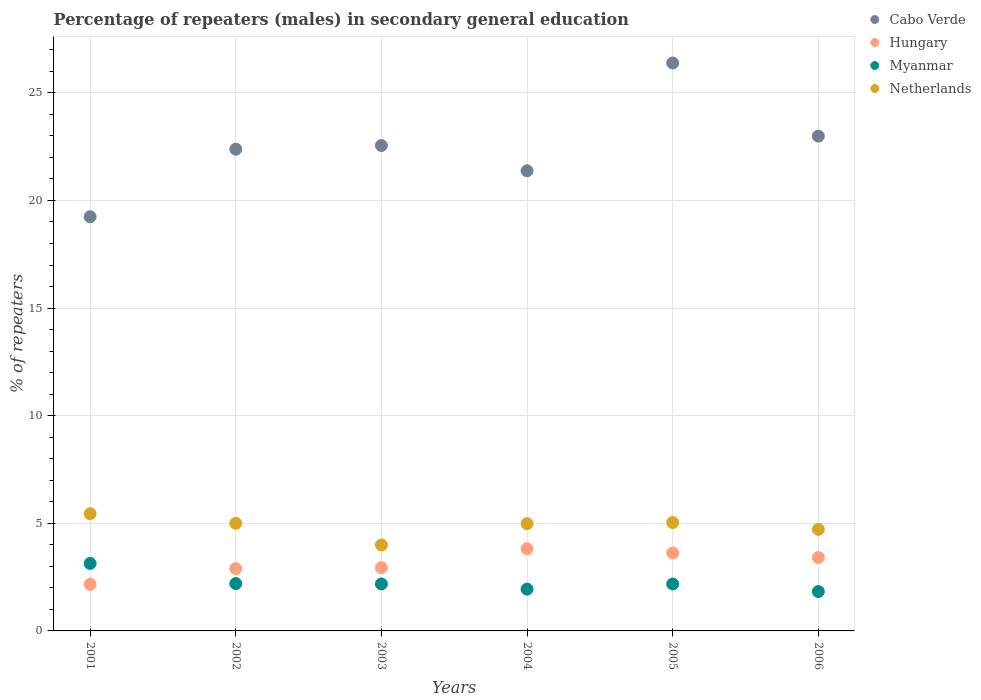How many different coloured dotlines are there?
Provide a succinct answer. 4. Is the number of dotlines equal to the number of legend labels?
Offer a very short reply. Yes. What is the percentage of male repeaters in Hungary in 2001?
Offer a very short reply. 2.16. Across all years, what is the maximum percentage of male repeaters in Cabo Verde?
Make the answer very short. 26.39. Across all years, what is the minimum percentage of male repeaters in Myanmar?
Make the answer very short. 1.83. What is the total percentage of male repeaters in Myanmar in the graph?
Provide a short and direct response. 13.47. What is the difference between the percentage of male repeaters in Myanmar in 2001 and that in 2005?
Offer a very short reply. 0.95. What is the difference between the percentage of male repeaters in Myanmar in 2002 and the percentage of male repeaters in Cabo Verde in 2003?
Offer a terse response. -20.35. What is the average percentage of male repeaters in Hungary per year?
Provide a short and direct response. 3.14. In the year 2002, what is the difference between the percentage of male repeaters in Hungary and percentage of male repeaters in Cabo Verde?
Your response must be concise. -19.49. In how many years, is the percentage of male repeaters in Hungary greater than 16 %?
Make the answer very short. 0. What is the ratio of the percentage of male repeaters in Netherlands in 2001 to that in 2003?
Give a very brief answer. 1.36. Is the difference between the percentage of male repeaters in Hungary in 2004 and 2005 greater than the difference between the percentage of male repeaters in Cabo Verde in 2004 and 2005?
Provide a short and direct response. Yes. What is the difference between the highest and the second highest percentage of male repeaters in Hungary?
Keep it short and to the point. 0.2. What is the difference between the highest and the lowest percentage of male repeaters in Cabo Verde?
Offer a very short reply. 7.14. Is the sum of the percentage of male repeaters in Hungary in 2002 and 2006 greater than the maximum percentage of male repeaters in Myanmar across all years?
Your answer should be compact. Yes. Is it the case that in every year, the sum of the percentage of male repeaters in Cabo Verde and percentage of male repeaters in Myanmar  is greater than the sum of percentage of male repeaters in Netherlands and percentage of male repeaters in Hungary?
Provide a succinct answer. No. Does the percentage of male repeaters in Netherlands monotonically increase over the years?
Your response must be concise. No. Is the percentage of male repeaters in Cabo Verde strictly greater than the percentage of male repeaters in Myanmar over the years?
Give a very brief answer. Yes. How many dotlines are there?
Keep it short and to the point. 4. Are the values on the major ticks of Y-axis written in scientific E-notation?
Give a very brief answer. No. Does the graph contain grids?
Your response must be concise. Yes. How many legend labels are there?
Your response must be concise. 4. What is the title of the graph?
Your response must be concise. Percentage of repeaters (males) in secondary general education. Does "Macedonia" appear as one of the legend labels in the graph?
Make the answer very short. No. What is the label or title of the X-axis?
Provide a succinct answer. Years. What is the label or title of the Y-axis?
Make the answer very short. % of repeaters. What is the % of repeaters of Cabo Verde in 2001?
Make the answer very short. 19.24. What is the % of repeaters in Hungary in 2001?
Keep it short and to the point. 2.16. What is the % of repeaters in Myanmar in 2001?
Offer a terse response. 3.13. What is the % of repeaters of Netherlands in 2001?
Keep it short and to the point. 5.45. What is the % of repeaters in Cabo Verde in 2002?
Your answer should be very brief. 22.38. What is the % of repeaters in Hungary in 2002?
Your answer should be very brief. 2.89. What is the % of repeaters in Myanmar in 2002?
Provide a short and direct response. 2.2. What is the % of repeaters in Netherlands in 2002?
Offer a very short reply. 5. What is the % of repeaters in Cabo Verde in 2003?
Keep it short and to the point. 22.55. What is the % of repeaters in Hungary in 2003?
Ensure brevity in your answer.  2.94. What is the % of repeaters in Myanmar in 2003?
Give a very brief answer. 2.18. What is the % of repeaters in Netherlands in 2003?
Ensure brevity in your answer.  3.99. What is the % of repeaters in Cabo Verde in 2004?
Offer a very short reply. 21.38. What is the % of repeaters of Hungary in 2004?
Ensure brevity in your answer.  3.82. What is the % of repeaters in Myanmar in 2004?
Keep it short and to the point. 1.94. What is the % of repeaters in Netherlands in 2004?
Provide a succinct answer. 4.99. What is the % of repeaters in Cabo Verde in 2005?
Ensure brevity in your answer.  26.39. What is the % of repeaters in Hungary in 2005?
Your answer should be compact. 3.62. What is the % of repeaters of Myanmar in 2005?
Give a very brief answer. 2.18. What is the % of repeaters in Netherlands in 2005?
Keep it short and to the point. 5.04. What is the % of repeaters of Cabo Verde in 2006?
Your answer should be compact. 22.99. What is the % of repeaters of Hungary in 2006?
Your answer should be compact. 3.41. What is the % of repeaters in Myanmar in 2006?
Your answer should be compact. 1.83. What is the % of repeaters of Netherlands in 2006?
Your answer should be compact. 4.72. Across all years, what is the maximum % of repeaters of Cabo Verde?
Offer a very short reply. 26.39. Across all years, what is the maximum % of repeaters in Hungary?
Provide a succinct answer. 3.82. Across all years, what is the maximum % of repeaters of Myanmar?
Your answer should be compact. 3.13. Across all years, what is the maximum % of repeaters of Netherlands?
Give a very brief answer. 5.45. Across all years, what is the minimum % of repeaters of Cabo Verde?
Give a very brief answer. 19.24. Across all years, what is the minimum % of repeaters in Hungary?
Provide a succinct answer. 2.16. Across all years, what is the minimum % of repeaters of Myanmar?
Keep it short and to the point. 1.83. Across all years, what is the minimum % of repeaters in Netherlands?
Your answer should be very brief. 3.99. What is the total % of repeaters in Cabo Verde in the graph?
Ensure brevity in your answer.  134.93. What is the total % of repeaters of Hungary in the graph?
Keep it short and to the point. 18.85. What is the total % of repeaters in Myanmar in the graph?
Your response must be concise. 13.47. What is the total % of repeaters in Netherlands in the graph?
Ensure brevity in your answer.  29.18. What is the difference between the % of repeaters of Cabo Verde in 2001 and that in 2002?
Your answer should be compact. -3.14. What is the difference between the % of repeaters of Hungary in 2001 and that in 2002?
Your answer should be compact. -0.73. What is the difference between the % of repeaters in Myanmar in 2001 and that in 2002?
Your answer should be very brief. 0.94. What is the difference between the % of repeaters in Netherlands in 2001 and that in 2002?
Your answer should be very brief. 0.45. What is the difference between the % of repeaters of Cabo Verde in 2001 and that in 2003?
Provide a short and direct response. -3.31. What is the difference between the % of repeaters of Hungary in 2001 and that in 2003?
Your response must be concise. -0.78. What is the difference between the % of repeaters in Myanmar in 2001 and that in 2003?
Offer a terse response. 0.95. What is the difference between the % of repeaters in Netherlands in 2001 and that in 2003?
Your response must be concise. 1.46. What is the difference between the % of repeaters in Cabo Verde in 2001 and that in 2004?
Keep it short and to the point. -2.13. What is the difference between the % of repeaters of Hungary in 2001 and that in 2004?
Your answer should be compact. -1.65. What is the difference between the % of repeaters in Myanmar in 2001 and that in 2004?
Provide a short and direct response. 1.19. What is the difference between the % of repeaters of Netherlands in 2001 and that in 2004?
Keep it short and to the point. 0.46. What is the difference between the % of repeaters in Cabo Verde in 2001 and that in 2005?
Ensure brevity in your answer.  -7.14. What is the difference between the % of repeaters in Hungary in 2001 and that in 2005?
Make the answer very short. -1.46. What is the difference between the % of repeaters of Myanmar in 2001 and that in 2005?
Offer a very short reply. 0.95. What is the difference between the % of repeaters in Netherlands in 2001 and that in 2005?
Provide a succinct answer. 0.41. What is the difference between the % of repeaters in Cabo Verde in 2001 and that in 2006?
Your answer should be very brief. -3.74. What is the difference between the % of repeaters of Hungary in 2001 and that in 2006?
Provide a short and direct response. -1.25. What is the difference between the % of repeaters in Myanmar in 2001 and that in 2006?
Give a very brief answer. 1.31. What is the difference between the % of repeaters in Netherlands in 2001 and that in 2006?
Keep it short and to the point. 0.73. What is the difference between the % of repeaters in Cabo Verde in 2002 and that in 2003?
Your answer should be compact. -0.17. What is the difference between the % of repeaters of Hungary in 2002 and that in 2003?
Give a very brief answer. -0.05. What is the difference between the % of repeaters of Myanmar in 2002 and that in 2003?
Ensure brevity in your answer.  0.02. What is the difference between the % of repeaters of Netherlands in 2002 and that in 2003?
Your answer should be very brief. 1.01. What is the difference between the % of repeaters in Hungary in 2002 and that in 2004?
Offer a very short reply. -0.93. What is the difference between the % of repeaters in Myanmar in 2002 and that in 2004?
Your response must be concise. 0.26. What is the difference between the % of repeaters of Netherlands in 2002 and that in 2004?
Offer a terse response. 0.01. What is the difference between the % of repeaters of Cabo Verde in 2002 and that in 2005?
Make the answer very short. -4. What is the difference between the % of repeaters in Hungary in 2002 and that in 2005?
Your answer should be compact. -0.73. What is the difference between the % of repeaters of Myanmar in 2002 and that in 2005?
Provide a succinct answer. 0.02. What is the difference between the % of repeaters in Netherlands in 2002 and that in 2005?
Provide a short and direct response. -0.04. What is the difference between the % of repeaters in Cabo Verde in 2002 and that in 2006?
Provide a succinct answer. -0.61. What is the difference between the % of repeaters of Hungary in 2002 and that in 2006?
Your answer should be very brief. -0.52. What is the difference between the % of repeaters in Myanmar in 2002 and that in 2006?
Your answer should be very brief. 0.37. What is the difference between the % of repeaters in Netherlands in 2002 and that in 2006?
Your answer should be compact. 0.28. What is the difference between the % of repeaters in Cabo Verde in 2003 and that in 2004?
Your answer should be very brief. 1.18. What is the difference between the % of repeaters of Hungary in 2003 and that in 2004?
Your answer should be compact. -0.88. What is the difference between the % of repeaters of Myanmar in 2003 and that in 2004?
Offer a very short reply. 0.24. What is the difference between the % of repeaters of Netherlands in 2003 and that in 2004?
Give a very brief answer. -0.99. What is the difference between the % of repeaters in Cabo Verde in 2003 and that in 2005?
Make the answer very short. -3.83. What is the difference between the % of repeaters in Hungary in 2003 and that in 2005?
Your response must be concise. -0.68. What is the difference between the % of repeaters in Myanmar in 2003 and that in 2005?
Give a very brief answer. 0. What is the difference between the % of repeaters in Netherlands in 2003 and that in 2005?
Provide a short and direct response. -1.04. What is the difference between the % of repeaters in Cabo Verde in 2003 and that in 2006?
Your answer should be very brief. -0.44. What is the difference between the % of repeaters in Hungary in 2003 and that in 2006?
Provide a succinct answer. -0.47. What is the difference between the % of repeaters of Myanmar in 2003 and that in 2006?
Your answer should be compact. 0.35. What is the difference between the % of repeaters in Netherlands in 2003 and that in 2006?
Offer a very short reply. -0.73. What is the difference between the % of repeaters of Cabo Verde in 2004 and that in 2005?
Offer a very short reply. -5.01. What is the difference between the % of repeaters of Hungary in 2004 and that in 2005?
Offer a terse response. 0.2. What is the difference between the % of repeaters of Myanmar in 2004 and that in 2005?
Your response must be concise. -0.24. What is the difference between the % of repeaters in Netherlands in 2004 and that in 2005?
Offer a terse response. -0.05. What is the difference between the % of repeaters of Cabo Verde in 2004 and that in 2006?
Provide a short and direct response. -1.61. What is the difference between the % of repeaters in Hungary in 2004 and that in 2006?
Your response must be concise. 0.41. What is the difference between the % of repeaters in Myanmar in 2004 and that in 2006?
Offer a terse response. 0.11. What is the difference between the % of repeaters of Netherlands in 2004 and that in 2006?
Your answer should be very brief. 0.26. What is the difference between the % of repeaters in Cabo Verde in 2005 and that in 2006?
Make the answer very short. 3.4. What is the difference between the % of repeaters in Hungary in 2005 and that in 2006?
Provide a succinct answer. 0.21. What is the difference between the % of repeaters of Myanmar in 2005 and that in 2006?
Your answer should be compact. 0.35. What is the difference between the % of repeaters in Netherlands in 2005 and that in 2006?
Offer a very short reply. 0.31. What is the difference between the % of repeaters of Cabo Verde in 2001 and the % of repeaters of Hungary in 2002?
Keep it short and to the point. 16.35. What is the difference between the % of repeaters of Cabo Verde in 2001 and the % of repeaters of Myanmar in 2002?
Ensure brevity in your answer.  17.05. What is the difference between the % of repeaters in Cabo Verde in 2001 and the % of repeaters in Netherlands in 2002?
Your answer should be very brief. 14.24. What is the difference between the % of repeaters in Hungary in 2001 and the % of repeaters in Myanmar in 2002?
Provide a short and direct response. -0.03. What is the difference between the % of repeaters in Hungary in 2001 and the % of repeaters in Netherlands in 2002?
Make the answer very short. -2.84. What is the difference between the % of repeaters in Myanmar in 2001 and the % of repeaters in Netherlands in 2002?
Offer a terse response. -1.87. What is the difference between the % of repeaters of Cabo Verde in 2001 and the % of repeaters of Hungary in 2003?
Keep it short and to the point. 16.3. What is the difference between the % of repeaters in Cabo Verde in 2001 and the % of repeaters in Myanmar in 2003?
Offer a very short reply. 17.06. What is the difference between the % of repeaters of Cabo Verde in 2001 and the % of repeaters of Netherlands in 2003?
Your answer should be very brief. 15.25. What is the difference between the % of repeaters of Hungary in 2001 and the % of repeaters of Myanmar in 2003?
Make the answer very short. -0.02. What is the difference between the % of repeaters of Hungary in 2001 and the % of repeaters of Netherlands in 2003?
Keep it short and to the point. -1.83. What is the difference between the % of repeaters in Myanmar in 2001 and the % of repeaters in Netherlands in 2003?
Keep it short and to the point. -0.86. What is the difference between the % of repeaters in Cabo Verde in 2001 and the % of repeaters in Hungary in 2004?
Your answer should be compact. 15.43. What is the difference between the % of repeaters of Cabo Verde in 2001 and the % of repeaters of Myanmar in 2004?
Offer a terse response. 17.3. What is the difference between the % of repeaters in Cabo Verde in 2001 and the % of repeaters in Netherlands in 2004?
Your answer should be very brief. 14.26. What is the difference between the % of repeaters of Hungary in 2001 and the % of repeaters of Myanmar in 2004?
Offer a very short reply. 0.22. What is the difference between the % of repeaters of Hungary in 2001 and the % of repeaters of Netherlands in 2004?
Keep it short and to the point. -2.82. What is the difference between the % of repeaters of Myanmar in 2001 and the % of repeaters of Netherlands in 2004?
Offer a terse response. -1.85. What is the difference between the % of repeaters in Cabo Verde in 2001 and the % of repeaters in Hungary in 2005?
Offer a terse response. 15.62. What is the difference between the % of repeaters of Cabo Verde in 2001 and the % of repeaters of Myanmar in 2005?
Your response must be concise. 17.06. What is the difference between the % of repeaters of Cabo Verde in 2001 and the % of repeaters of Netherlands in 2005?
Offer a very short reply. 14.21. What is the difference between the % of repeaters in Hungary in 2001 and the % of repeaters in Myanmar in 2005?
Ensure brevity in your answer.  -0.02. What is the difference between the % of repeaters of Hungary in 2001 and the % of repeaters of Netherlands in 2005?
Offer a very short reply. -2.87. What is the difference between the % of repeaters of Myanmar in 2001 and the % of repeaters of Netherlands in 2005?
Provide a short and direct response. -1.9. What is the difference between the % of repeaters in Cabo Verde in 2001 and the % of repeaters in Hungary in 2006?
Your response must be concise. 15.83. What is the difference between the % of repeaters of Cabo Verde in 2001 and the % of repeaters of Myanmar in 2006?
Keep it short and to the point. 17.41. What is the difference between the % of repeaters in Cabo Verde in 2001 and the % of repeaters in Netherlands in 2006?
Keep it short and to the point. 14.52. What is the difference between the % of repeaters of Hungary in 2001 and the % of repeaters of Myanmar in 2006?
Your answer should be compact. 0.34. What is the difference between the % of repeaters of Hungary in 2001 and the % of repeaters of Netherlands in 2006?
Ensure brevity in your answer.  -2.56. What is the difference between the % of repeaters of Myanmar in 2001 and the % of repeaters of Netherlands in 2006?
Give a very brief answer. -1.59. What is the difference between the % of repeaters of Cabo Verde in 2002 and the % of repeaters of Hungary in 2003?
Provide a succinct answer. 19.44. What is the difference between the % of repeaters in Cabo Verde in 2002 and the % of repeaters in Myanmar in 2003?
Provide a short and direct response. 20.2. What is the difference between the % of repeaters in Cabo Verde in 2002 and the % of repeaters in Netherlands in 2003?
Give a very brief answer. 18.39. What is the difference between the % of repeaters of Hungary in 2002 and the % of repeaters of Myanmar in 2003?
Offer a very short reply. 0.71. What is the difference between the % of repeaters in Hungary in 2002 and the % of repeaters in Netherlands in 2003?
Your answer should be very brief. -1.1. What is the difference between the % of repeaters in Myanmar in 2002 and the % of repeaters in Netherlands in 2003?
Provide a succinct answer. -1.79. What is the difference between the % of repeaters in Cabo Verde in 2002 and the % of repeaters in Hungary in 2004?
Provide a short and direct response. 18.56. What is the difference between the % of repeaters in Cabo Verde in 2002 and the % of repeaters in Myanmar in 2004?
Give a very brief answer. 20.44. What is the difference between the % of repeaters of Cabo Verde in 2002 and the % of repeaters of Netherlands in 2004?
Provide a short and direct response. 17.4. What is the difference between the % of repeaters in Hungary in 2002 and the % of repeaters in Myanmar in 2004?
Offer a very short reply. 0.95. What is the difference between the % of repeaters in Hungary in 2002 and the % of repeaters in Netherlands in 2004?
Offer a terse response. -2.09. What is the difference between the % of repeaters in Myanmar in 2002 and the % of repeaters in Netherlands in 2004?
Make the answer very short. -2.79. What is the difference between the % of repeaters in Cabo Verde in 2002 and the % of repeaters in Hungary in 2005?
Ensure brevity in your answer.  18.76. What is the difference between the % of repeaters of Cabo Verde in 2002 and the % of repeaters of Myanmar in 2005?
Your answer should be very brief. 20.2. What is the difference between the % of repeaters in Cabo Verde in 2002 and the % of repeaters in Netherlands in 2005?
Your answer should be very brief. 17.35. What is the difference between the % of repeaters of Hungary in 2002 and the % of repeaters of Myanmar in 2005?
Give a very brief answer. 0.71. What is the difference between the % of repeaters in Hungary in 2002 and the % of repeaters in Netherlands in 2005?
Offer a terse response. -2.14. What is the difference between the % of repeaters in Myanmar in 2002 and the % of repeaters in Netherlands in 2005?
Keep it short and to the point. -2.84. What is the difference between the % of repeaters of Cabo Verde in 2002 and the % of repeaters of Hungary in 2006?
Make the answer very short. 18.97. What is the difference between the % of repeaters in Cabo Verde in 2002 and the % of repeaters in Myanmar in 2006?
Provide a short and direct response. 20.55. What is the difference between the % of repeaters of Cabo Verde in 2002 and the % of repeaters of Netherlands in 2006?
Give a very brief answer. 17.66. What is the difference between the % of repeaters in Hungary in 2002 and the % of repeaters in Myanmar in 2006?
Provide a succinct answer. 1.06. What is the difference between the % of repeaters of Hungary in 2002 and the % of repeaters of Netherlands in 2006?
Keep it short and to the point. -1.83. What is the difference between the % of repeaters of Myanmar in 2002 and the % of repeaters of Netherlands in 2006?
Provide a succinct answer. -2.52. What is the difference between the % of repeaters in Cabo Verde in 2003 and the % of repeaters in Hungary in 2004?
Offer a very short reply. 18.73. What is the difference between the % of repeaters of Cabo Verde in 2003 and the % of repeaters of Myanmar in 2004?
Provide a succinct answer. 20.61. What is the difference between the % of repeaters of Cabo Verde in 2003 and the % of repeaters of Netherlands in 2004?
Keep it short and to the point. 17.57. What is the difference between the % of repeaters of Hungary in 2003 and the % of repeaters of Myanmar in 2004?
Offer a terse response. 1. What is the difference between the % of repeaters in Hungary in 2003 and the % of repeaters in Netherlands in 2004?
Give a very brief answer. -2.04. What is the difference between the % of repeaters in Myanmar in 2003 and the % of repeaters in Netherlands in 2004?
Make the answer very short. -2.8. What is the difference between the % of repeaters in Cabo Verde in 2003 and the % of repeaters in Hungary in 2005?
Your answer should be compact. 18.93. What is the difference between the % of repeaters in Cabo Verde in 2003 and the % of repeaters in Myanmar in 2005?
Your answer should be compact. 20.37. What is the difference between the % of repeaters of Cabo Verde in 2003 and the % of repeaters of Netherlands in 2005?
Your answer should be very brief. 17.52. What is the difference between the % of repeaters of Hungary in 2003 and the % of repeaters of Myanmar in 2005?
Ensure brevity in your answer.  0.76. What is the difference between the % of repeaters of Hungary in 2003 and the % of repeaters of Netherlands in 2005?
Provide a short and direct response. -2.09. What is the difference between the % of repeaters in Myanmar in 2003 and the % of repeaters in Netherlands in 2005?
Your answer should be very brief. -2.85. What is the difference between the % of repeaters in Cabo Verde in 2003 and the % of repeaters in Hungary in 2006?
Provide a short and direct response. 19.14. What is the difference between the % of repeaters in Cabo Verde in 2003 and the % of repeaters in Myanmar in 2006?
Give a very brief answer. 20.72. What is the difference between the % of repeaters of Cabo Verde in 2003 and the % of repeaters of Netherlands in 2006?
Ensure brevity in your answer.  17.83. What is the difference between the % of repeaters of Hungary in 2003 and the % of repeaters of Myanmar in 2006?
Provide a succinct answer. 1.11. What is the difference between the % of repeaters in Hungary in 2003 and the % of repeaters in Netherlands in 2006?
Give a very brief answer. -1.78. What is the difference between the % of repeaters in Myanmar in 2003 and the % of repeaters in Netherlands in 2006?
Your response must be concise. -2.54. What is the difference between the % of repeaters of Cabo Verde in 2004 and the % of repeaters of Hungary in 2005?
Offer a very short reply. 17.76. What is the difference between the % of repeaters in Cabo Verde in 2004 and the % of repeaters in Myanmar in 2005?
Provide a short and direct response. 19.2. What is the difference between the % of repeaters of Cabo Verde in 2004 and the % of repeaters of Netherlands in 2005?
Provide a short and direct response. 16.34. What is the difference between the % of repeaters in Hungary in 2004 and the % of repeaters in Myanmar in 2005?
Offer a very short reply. 1.64. What is the difference between the % of repeaters in Hungary in 2004 and the % of repeaters in Netherlands in 2005?
Your answer should be very brief. -1.22. What is the difference between the % of repeaters of Myanmar in 2004 and the % of repeaters of Netherlands in 2005?
Your answer should be compact. -3.09. What is the difference between the % of repeaters of Cabo Verde in 2004 and the % of repeaters of Hungary in 2006?
Offer a very short reply. 17.97. What is the difference between the % of repeaters in Cabo Verde in 2004 and the % of repeaters in Myanmar in 2006?
Keep it short and to the point. 19.55. What is the difference between the % of repeaters in Cabo Verde in 2004 and the % of repeaters in Netherlands in 2006?
Give a very brief answer. 16.66. What is the difference between the % of repeaters of Hungary in 2004 and the % of repeaters of Myanmar in 2006?
Your response must be concise. 1.99. What is the difference between the % of repeaters of Hungary in 2004 and the % of repeaters of Netherlands in 2006?
Ensure brevity in your answer.  -0.9. What is the difference between the % of repeaters of Myanmar in 2004 and the % of repeaters of Netherlands in 2006?
Ensure brevity in your answer.  -2.78. What is the difference between the % of repeaters of Cabo Verde in 2005 and the % of repeaters of Hungary in 2006?
Provide a short and direct response. 22.97. What is the difference between the % of repeaters in Cabo Verde in 2005 and the % of repeaters in Myanmar in 2006?
Your answer should be very brief. 24.56. What is the difference between the % of repeaters of Cabo Verde in 2005 and the % of repeaters of Netherlands in 2006?
Keep it short and to the point. 21.66. What is the difference between the % of repeaters of Hungary in 2005 and the % of repeaters of Myanmar in 2006?
Offer a very short reply. 1.79. What is the difference between the % of repeaters in Hungary in 2005 and the % of repeaters in Netherlands in 2006?
Your answer should be very brief. -1.1. What is the difference between the % of repeaters in Myanmar in 2005 and the % of repeaters in Netherlands in 2006?
Offer a terse response. -2.54. What is the average % of repeaters of Cabo Verde per year?
Make the answer very short. 22.49. What is the average % of repeaters in Hungary per year?
Offer a very short reply. 3.14. What is the average % of repeaters of Myanmar per year?
Provide a short and direct response. 2.24. What is the average % of repeaters of Netherlands per year?
Offer a very short reply. 4.86. In the year 2001, what is the difference between the % of repeaters of Cabo Verde and % of repeaters of Hungary?
Ensure brevity in your answer.  17.08. In the year 2001, what is the difference between the % of repeaters of Cabo Verde and % of repeaters of Myanmar?
Give a very brief answer. 16.11. In the year 2001, what is the difference between the % of repeaters in Cabo Verde and % of repeaters in Netherlands?
Provide a succinct answer. 13.8. In the year 2001, what is the difference between the % of repeaters in Hungary and % of repeaters in Myanmar?
Offer a terse response. -0.97. In the year 2001, what is the difference between the % of repeaters of Hungary and % of repeaters of Netherlands?
Ensure brevity in your answer.  -3.28. In the year 2001, what is the difference between the % of repeaters in Myanmar and % of repeaters in Netherlands?
Provide a succinct answer. -2.31. In the year 2002, what is the difference between the % of repeaters in Cabo Verde and % of repeaters in Hungary?
Offer a terse response. 19.49. In the year 2002, what is the difference between the % of repeaters in Cabo Verde and % of repeaters in Myanmar?
Your answer should be very brief. 20.18. In the year 2002, what is the difference between the % of repeaters of Cabo Verde and % of repeaters of Netherlands?
Your response must be concise. 17.38. In the year 2002, what is the difference between the % of repeaters in Hungary and % of repeaters in Myanmar?
Keep it short and to the point. 0.69. In the year 2002, what is the difference between the % of repeaters in Hungary and % of repeaters in Netherlands?
Provide a short and direct response. -2.11. In the year 2002, what is the difference between the % of repeaters in Myanmar and % of repeaters in Netherlands?
Ensure brevity in your answer.  -2.8. In the year 2003, what is the difference between the % of repeaters in Cabo Verde and % of repeaters in Hungary?
Your answer should be very brief. 19.61. In the year 2003, what is the difference between the % of repeaters of Cabo Verde and % of repeaters of Myanmar?
Offer a very short reply. 20.37. In the year 2003, what is the difference between the % of repeaters in Cabo Verde and % of repeaters in Netherlands?
Your answer should be very brief. 18.56. In the year 2003, what is the difference between the % of repeaters in Hungary and % of repeaters in Myanmar?
Your answer should be compact. 0.76. In the year 2003, what is the difference between the % of repeaters in Hungary and % of repeaters in Netherlands?
Keep it short and to the point. -1.05. In the year 2003, what is the difference between the % of repeaters in Myanmar and % of repeaters in Netherlands?
Your response must be concise. -1.81. In the year 2004, what is the difference between the % of repeaters in Cabo Verde and % of repeaters in Hungary?
Provide a succinct answer. 17.56. In the year 2004, what is the difference between the % of repeaters of Cabo Verde and % of repeaters of Myanmar?
Your answer should be compact. 19.44. In the year 2004, what is the difference between the % of repeaters of Cabo Verde and % of repeaters of Netherlands?
Make the answer very short. 16.39. In the year 2004, what is the difference between the % of repeaters of Hungary and % of repeaters of Myanmar?
Provide a succinct answer. 1.88. In the year 2004, what is the difference between the % of repeaters of Hungary and % of repeaters of Netherlands?
Give a very brief answer. -1.17. In the year 2004, what is the difference between the % of repeaters of Myanmar and % of repeaters of Netherlands?
Provide a succinct answer. -3.04. In the year 2005, what is the difference between the % of repeaters in Cabo Verde and % of repeaters in Hungary?
Ensure brevity in your answer.  22.76. In the year 2005, what is the difference between the % of repeaters in Cabo Verde and % of repeaters in Myanmar?
Your answer should be very brief. 24.21. In the year 2005, what is the difference between the % of repeaters of Cabo Verde and % of repeaters of Netherlands?
Your answer should be very brief. 21.35. In the year 2005, what is the difference between the % of repeaters in Hungary and % of repeaters in Myanmar?
Ensure brevity in your answer.  1.44. In the year 2005, what is the difference between the % of repeaters in Hungary and % of repeaters in Netherlands?
Your answer should be very brief. -1.41. In the year 2005, what is the difference between the % of repeaters in Myanmar and % of repeaters in Netherlands?
Your answer should be compact. -2.86. In the year 2006, what is the difference between the % of repeaters in Cabo Verde and % of repeaters in Hungary?
Your answer should be very brief. 19.58. In the year 2006, what is the difference between the % of repeaters of Cabo Verde and % of repeaters of Myanmar?
Keep it short and to the point. 21.16. In the year 2006, what is the difference between the % of repeaters of Cabo Verde and % of repeaters of Netherlands?
Your answer should be very brief. 18.27. In the year 2006, what is the difference between the % of repeaters in Hungary and % of repeaters in Myanmar?
Your response must be concise. 1.58. In the year 2006, what is the difference between the % of repeaters in Hungary and % of repeaters in Netherlands?
Offer a very short reply. -1.31. In the year 2006, what is the difference between the % of repeaters of Myanmar and % of repeaters of Netherlands?
Keep it short and to the point. -2.89. What is the ratio of the % of repeaters of Cabo Verde in 2001 to that in 2002?
Keep it short and to the point. 0.86. What is the ratio of the % of repeaters of Hungary in 2001 to that in 2002?
Make the answer very short. 0.75. What is the ratio of the % of repeaters of Myanmar in 2001 to that in 2002?
Provide a succinct answer. 1.43. What is the ratio of the % of repeaters of Netherlands in 2001 to that in 2002?
Make the answer very short. 1.09. What is the ratio of the % of repeaters in Cabo Verde in 2001 to that in 2003?
Provide a succinct answer. 0.85. What is the ratio of the % of repeaters of Hungary in 2001 to that in 2003?
Ensure brevity in your answer.  0.74. What is the ratio of the % of repeaters in Myanmar in 2001 to that in 2003?
Provide a short and direct response. 1.44. What is the ratio of the % of repeaters in Netherlands in 2001 to that in 2003?
Offer a terse response. 1.36. What is the ratio of the % of repeaters of Cabo Verde in 2001 to that in 2004?
Your response must be concise. 0.9. What is the ratio of the % of repeaters of Hungary in 2001 to that in 2004?
Keep it short and to the point. 0.57. What is the ratio of the % of repeaters of Myanmar in 2001 to that in 2004?
Your response must be concise. 1.61. What is the ratio of the % of repeaters of Netherlands in 2001 to that in 2004?
Your answer should be very brief. 1.09. What is the ratio of the % of repeaters in Cabo Verde in 2001 to that in 2005?
Your response must be concise. 0.73. What is the ratio of the % of repeaters of Hungary in 2001 to that in 2005?
Your answer should be very brief. 0.6. What is the ratio of the % of repeaters of Myanmar in 2001 to that in 2005?
Offer a very short reply. 1.44. What is the ratio of the % of repeaters in Netherlands in 2001 to that in 2005?
Offer a very short reply. 1.08. What is the ratio of the % of repeaters of Cabo Verde in 2001 to that in 2006?
Offer a terse response. 0.84. What is the ratio of the % of repeaters of Hungary in 2001 to that in 2006?
Offer a very short reply. 0.63. What is the ratio of the % of repeaters in Myanmar in 2001 to that in 2006?
Your answer should be very brief. 1.71. What is the ratio of the % of repeaters in Netherlands in 2001 to that in 2006?
Give a very brief answer. 1.15. What is the ratio of the % of repeaters in Hungary in 2002 to that in 2003?
Ensure brevity in your answer.  0.98. What is the ratio of the % of repeaters of Myanmar in 2002 to that in 2003?
Your answer should be very brief. 1.01. What is the ratio of the % of repeaters in Netherlands in 2002 to that in 2003?
Your response must be concise. 1.25. What is the ratio of the % of repeaters in Cabo Verde in 2002 to that in 2004?
Give a very brief answer. 1.05. What is the ratio of the % of repeaters of Hungary in 2002 to that in 2004?
Give a very brief answer. 0.76. What is the ratio of the % of repeaters of Myanmar in 2002 to that in 2004?
Give a very brief answer. 1.13. What is the ratio of the % of repeaters of Cabo Verde in 2002 to that in 2005?
Make the answer very short. 0.85. What is the ratio of the % of repeaters of Hungary in 2002 to that in 2005?
Your response must be concise. 0.8. What is the ratio of the % of repeaters in Myanmar in 2002 to that in 2005?
Give a very brief answer. 1.01. What is the ratio of the % of repeaters in Cabo Verde in 2002 to that in 2006?
Give a very brief answer. 0.97. What is the ratio of the % of repeaters of Hungary in 2002 to that in 2006?
Your answer should be very brief. 0.85. What is the ratio of the % of repeaters in Myanmar in 2002 to that in 2006?
Your answer should be very brief. 1.2. What is the ratio of the % of repeaters of Netherlands in 2002 to that in 2006?
Offer a terse response. 1.06. What is the ratio of the % of repeaters in Cabo Verde in 2003 to that in 2004?
Keep it short and to the point. 1.05. What is the ratio of the % of repeaters in Hungary in 2003 to that in 2004?
Offer a very short reply. 0.77. What is the ratio of the % of repeaters of Myanmar in 2003 to that in 2004?
Offer a very short reply. 1.12. What is the ratio of the % of repeaters in Netherlands in 2003 to that in 2004?
Keep it short and to the point. 0.8. What is the ratio of the % of repeaters of Cabo Verde in 2003 to that in 2005?
Make the answer very short. 0.85. What is the ratio of the % of repeaters in Hungary in 2003 to that in 2005?
Provide a short and direct response. 0.81. What is the ratio of the % of repeaters of Netherlands in 2003 to that in 2005?
Offer a very short reply. 0.79. What is the ratio of the % of repeaters of Cabo Verde in 2003 to that in 2006?
Provide a short and direct response. 0.98. What is the ratio of the % of repeaters of Hungary in 2003 to that in 2006?
Your answer should be very brief. 0.86. What is the ratio of the % of repeaters of Myanmar in 2003 to that in 2006?
Your answer should be compact. 1.19. What is the ratio of the % of repeaters of Netherlands in 2003 to that in 2006?
Offer a terse response. 0.85. What is the ratio of the % of repeaters of Cabo Verde in 2004 to that in 2005?
Ensure brevity in your answer.  0.81. What is the ratio of the % of repeaters in Hungary in 2004 to that in 2005?
Offer a very short reply. 1.05. What is the ratio of the % of repeaters in Myanmar in 2004 to that in 2005?
Make the answer very short. 0.89. What is the ratio of the % of repeaters of Netherlands in 2004 to that in 2005?
Your answer should be very brief. 0.99. What is the ratio of the % of repeaters in Cabo Verde in 2004 to that in 2006?
Ensure brevity in your answer.  0.93. What is the ratio of the % of repeaters in Hungary in 2004 to that in 2006?
Offer a very short reply. 1.12. What is the ratio of the % of repeaters in Myanmar in 2004 to that in 2006?
Keep it short and to the point. 1.06. What is the ratio of the % of repeaters of Netherlands in 2004 to that in 2006?
Your answer should be compact. 1.06. What is the ratio of the % of repeaters in Cabo Verde in 2005 to that in 2006?
Offer a very short reply. 1.15. What is the ratio of the % of repeaters of Hungary in 2005 to that in 2006?
Make the answer very short. 1.06. What is the ratio of the % of repeaters in Myanmar in 2005 to that in 2006?
Keep it short and to the point. 1.19. What is the ratio of the % of repeaters in Netherlands in 2005 to that in 2006?
Offer a terse response. 1.07. What is the difference between the highest and the second highest % of repeaters in Cabo Verde?
Offer a very short reply. 3.4. What is the difference between the highest and the second highest % of repeaters of Hungary?
Ensure brevity in your answer.  0.2. What is the difference between the highest and the second highest % of repeaters in Myanmar?
Give a very brief answer. 0.94. What is the difference between the highest and the second highest % of repeaters of Netherlands?
Provide a short and direct response. 0.41. What is the difference between the highest and the lowest % of repeaters of Cabo Verde?
Offer a terse response. 7.14. What is the difference between the highest and the lowest % of repeaters in Hungary?
Provide a short and direct response. 1.65. What is the difference between the highest and the lowest % of repeaters in Myanmar?
Keep it short and to the point. 1.31. What is the difference between the highest and the lowest % of repeaters of Netherlands?
Provide a succinct answer. 1.46. 